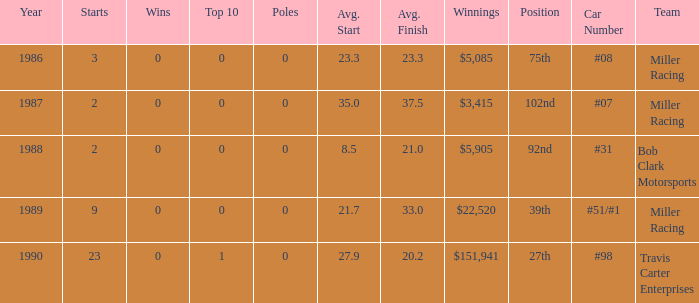What is the most recent year where the average start is 8.5? 1988.0. 